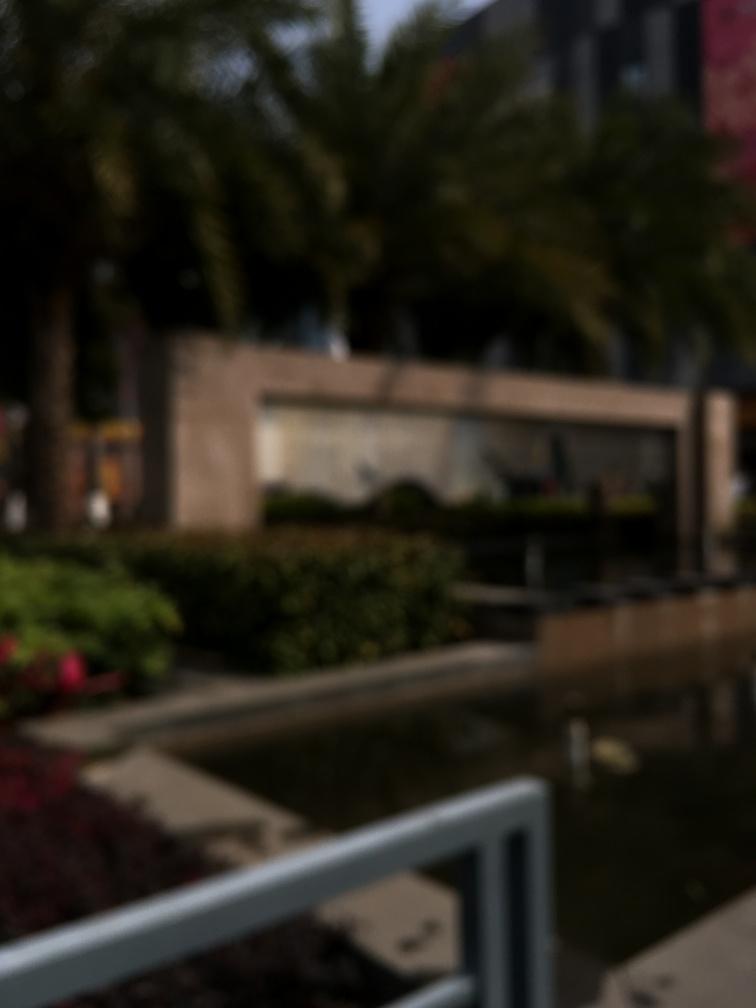What is the quality of this image? The quality of this image is poor since it is extremely blurry, making it difficult to discern any specific details such as the objects or the scene's context. 